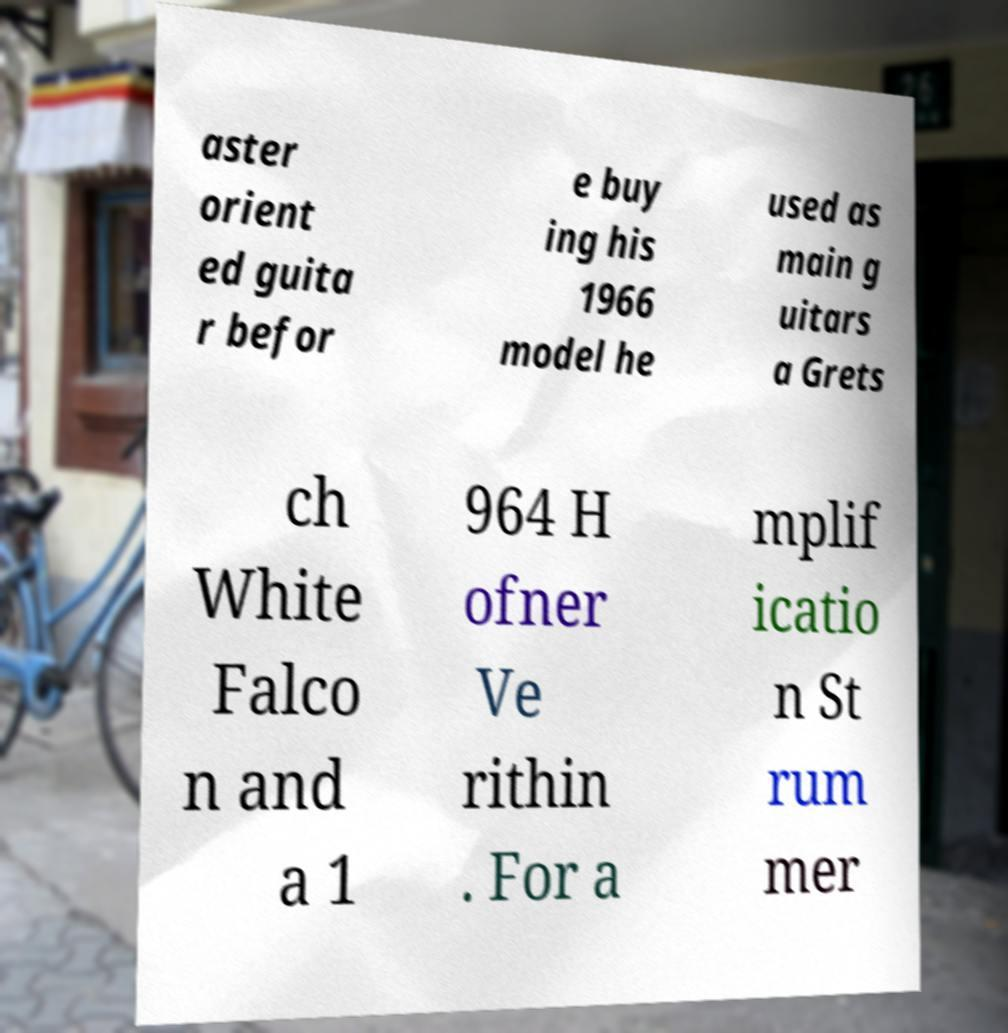Could you extract and type out the text from this image? aster orient ed guita r befor e buy ing his 1966 model he used as main g uitars a Grets ch White Falco n and a 1 964 H ofner Ve rithin . For a mplif icatio n St rum mer 